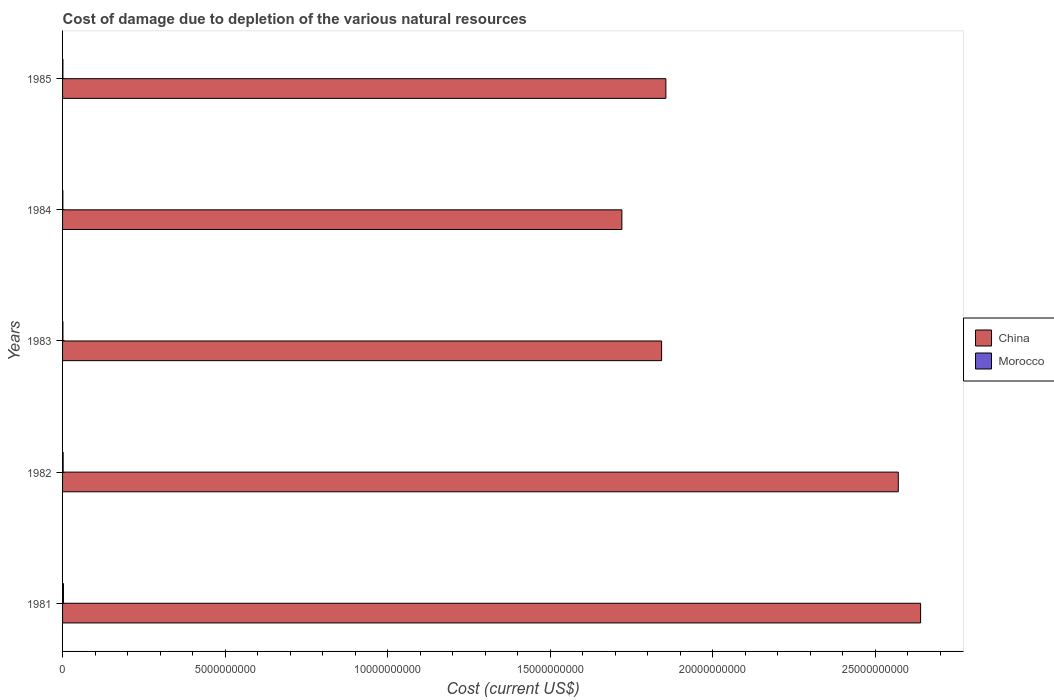How many different coloured bars are there?
Your answer should be very brief. 2. How many groups of bars are there?
Your response must be concise. 5. How many bars are there on the 2nd tick from the top?
Make the answer very short. 2. How many bars are there on the 2nd tick from the bottom?
Your answer should be very brief. 2. What is the label of the 4th group of bars from the top?
Ensure brevity in your answer.  1982. In how many cases, is the number of bars for a given year not equal to the number of legend labels?
Offer a terse response. 0. What is the cost of damage caused due to the depletion of various natural resources in China in 1985?
Offer a very short reply. 1.86e+1. Across all years, what is the maximum cost of damage caused due to the depletion of various natural resources in Morocco?
Make the answer very short. 2.79e+07. Across all years, what is the minimum cost of damage caused due to the depletion of various natural resources in Morocco?
Provide a succinct answer. 8.93e+06. In which year was the cost of damage caused due to the depletion of various natural resources in China maximum?
Offer a terse response. 1981. What is the total cost of damage caused due to the depletion of various natural resources in Morocco in the graph?
Provide a short and direct response. 7.70e+07. What is the difference between the cost of damage caused due to the depletion of various natural resources in Morocco in 1981 and that in 1985?
Give a very brief answer. 1.68e+07. What is the difference between the cost of damage caused due to the depletion of various natural resources in Morocco in 1981 and the cost of damage caused due to the depletion of various natural resources in China in 1983?
Ensure brevity in your answer.  -1.84e+1. What is the average cost of damage caused due to the depletion of various natural resources in Morocco per year?
Your answer should be very brief. 1.54e+07. In the year 1981, what is the difference between the cost of damage caused due to the depletion of various natural resources in China and cost of damage caused due to the depletion of various natural resources in Morocco?
Make the answer very short. 2.64e+1. What is the ratio of the cost of damage caused due to the depletion of various natural resources in Morocco in 1983 to that in 1984?
Provide a succinct answer. 1.24. What is the difference between the highest and the second highest cost of damage caused due to the depletion of various natural resources in China?
Your response must be concise. 6.87e+08. What is the difference between the highest and the lowest cost of damage caused due to the depletion of various natural resources in China?
Provide a short and direct response. 9.19e+09. In how many years, is the cost of damage caused due to the depletion of various natural resources in Morocco greater than the average cost of damage caused due to the depletion of various natural resources in Morocco taken over all years?
Provide a succinct answer. 2. What does the 1st bar from the top in 1982 represents?
Offer a terse response. Morocco. What does the 1st bar from the bottom in 1984 represents?
Offer a terse response. China. How many bars are there?
Your answer should be compact. 10. Does the graph contain any zero values?
Make the answer very short. No. How many legend labels are there?
Give a very brief answer. 2. How are the legend labels stacked?
Your answer should be compact. Vertical. What is the title of the graph?
Offer a terse response. Cost of damage due to depletion of the various natural resources. Does "Trinidad and Tobago" appear as one of the legend labels in the graph?
Offer a very short reply. No. What is the label or title of the X-axis?
Offer a very short reply. Cost (current US$). What is the label or title of the Y-axis?
Offer a terse response. Years. What is the Cost (current US$) in China in 1981?
Provide a succinct answer. 2.64e+1. What is the Cost (current US$) of Morocco in 1981?
Provide a succinct answer. 2.79e+07. What is the Cost (current US$) in China in 1982?
Keep it short and to the point. 2.57e+1. What is the Cost (current US$) in Morocco in 1982?
Your answer should be very brief. 1.80e+07. What is the Cost (current US$) in China in 1983?
Keep it short and to the point. 1.84e+1. What is the Cost (current US$) of Morocco in 1983?
Keep it short and to the point. 1.11e+07. What is the Cost (current US$) of China in 1984?
Provide a short and direct response. 1.72e+1. What is the Cost (current US$) in Morocco in 1984?
Ensure brevity in your answer.  8.93e+06. What is the Cost (current US$) of China in 1985?
Offer a terse response. 1.86e+1. What is the Cost (current US$) in Morocco in 1985?
Give a very brief answer. 1.12e+07. Across all years, what is the maximum Cost (current US$) in China?
Provide a succinct answer. 2.64e+1. Across all years, what is the maximum Cost (current US$) in Morocco?
Keep it short and to the point. 2.79e+07. Across all years, what is the minimum Cost (current US$) in China?
Your response must be concise. 1.72e+1. Across all years, what is the minimum Cost (current US$) in Morocco?
Make the answer very short. 8.93e+06. What is the total Cost (current US$) in China in the graph?
Offer a very short reply. 1.06e+11. What is the total Cost (current US$) of Morocco in the graph?
Provide a succinct answer. 7.70e+07. What is the difference between the Cost (current US$) of China in 1981 and that in 1982?
Your answer should be compact. 6.87e+08. What is the difference between the Cost (current US$) in Morocco in 1981 and that in 1982?
Your answer should be compact. 9.96e+06. What is the difference between the Cost (current US$) of China in 1981 and that in 1983?
Offer a terse response. 7.97e+09. What is the difference between the Cost (current US$) of Morocco in 1981 and that in 1983?
Give a very brief answer. 1.69e+07. What is the difference between the Cost (current US$) in China in 1981 and that in 1984?
Provide a succinct answer. 9.19e+09. What is the difference between the Cost (current US$) of Morocco in 1981 and that in 1984?
Ensure brevity in your answer.  1.90e+07. What is the difference between the Cost (current US$) of China in 1981 and that in 1985?
Make the answer very short. 7.84e+09. What is the difference between the Cost (current US$) in Morocco in 1981 and that in 1985?
Make the answer very short. 1.68e+07. What is the difference between the Cost (current US$) in China in 1982 and that in 1983?
Offer a very short reply. 7.28e+09. What is the difference between the Cost (current US$) of Morocco in 1982 and that in 1983?
Make the answer very short. 6.90e+06. What is the difference between the Cost (current US$) in China in 1982 and that in 1984?
Your response must be concise. 8.50e+09. What is the difference between the Cost (current US$) of Morocco in 1982 and that in 1984?
Your answer should be compact. 9.04e+06. What is the difference between the Cost (current US$) of China in 1982 and that in 1985?
Your response must be concise. 7.15e+09. What is the difference between the Cost (current US$) in Morocco in 1982 and that in 1985?
Provide a short and direct response. 6.82e+06. What is the difference between the Cost (current US$) of China in 1983 and that in 1984?
Provide a short and direct response. 1.22e+09. What is the difference between the Cost (current US$) in Morocco in 1983 and that in 1984?
Your answer should be very brief. 2.14e+06. What is the difference between the Cost (current US$) of China in 1983 and that in 1985?
Provide a succinct answer. -1.31e+08. What is the difference between the Cost (current US$) of Morocco in 1983 and that in 1985?
Provide a succinct answer. -8.16e+04. What is the difference between the Cost (current US$) in China in 1984 and that in 1985?
Your response must be concise. -1.35e+09. What is the difference between the Cost (current US$) of Morocco in 1984 and that in 1985?
Provide a succinct answer. -2.23e+06. What is the difference between the Cost (current US$) in China in 1981 and the Cost (current US$) in Morocco in 1982?
Your answer should be compact. 2.64e+1. What is the difference between the Cost (current US$) of China in 1981 and the Cost (current US$) of Morocco in 1983?
Keep it short and to the point. 2.64e+1. What is the difference between the Cost (current US$) of China in 1981 and the Cost (current US$) of Morocco in 1984?
Provide a short and direct response. 2.64e+1. What is the difference between the Cost (current US$) in China in 1981 and the Cost (current US$) in Morocco in 1985?
Provide a succinct answer. 2.64e+1. What is the difference between the Cost (current US$) of China in 1982 and the Cost (current US$) of Morocco in 1983?
Give a very brief answer. 2.57e+1. What is the difference between the Cost (current US$) in China in 1982 and the Cost (current US$) in Morocco in 1984?
Make the answer very short. 2.57e+1. What is the difference between the Cost (current US$) in China in 1982 and the Cost (current US$) in Morocco in 1985?
Your answer should be compact. 2.57e+1. What is the difference between the Cost (current US$) in China in 1983 and the Cost (current US$) in Morocco in 1984?
Keep it short and to the point. 1.84e+1. What is the difference between the Cost (current US$) of China in 1983 and the Cost (current US$) of Morocco in 1985?
Your answer should be compact. 1.84e+1. What is the difference between the Cost (current US$) of China in 1984 and the Cost (current US$) of Morocco in 1985?
Offer a terse response. 1.72e+1. What is the average Cost (current US$) in China per year?
Ensure brevity in your answer.  2.13e+1. What is the average Cost (current US$) of Morocco per year?
Make the answer very short. 1.54e+07. In the year 1981, what is the difference between the Cost (current US$) of China and Cost (current US$) of Morocco?
Your answer should be compact. 2.64e+1. In the year 1982, what is the difference between the Cost (current US$) in China and Cost (current US$) in Morocco?
Keep it short and to the point. 2.57e+1. In the year 1983, what is the difference between the Cost (current US$) in China and Cost (current US$) in Morocco?
Make the answer very short. 1.84e+1. In the year 1984, what is the difference between the Cost (current US$) of China and Cost (current US$) of Morocco?
Give a very brief answer. 1.72e+1. In the year 1985, what is the difference between the Cost (current US$) in China and Cost (current US$) in Morocco?
Offer a very short reply. 1.85e+1. What is the ratio of the Cost (current US$) of China in 1981 to that in 1982?
Your answer should be very brief. 1.03. What is the ratio of the Cost (current US$) of Morocco in 1981 to that in 1982?
Keep it short and to the point. 1.55. What is the ratio of the Cost (current US$) in China in 1981 to that in 1983?
Offer a very short reply. 1.43. What is the ratio of the Cost (current US$) in Morocco in 1981 to that in 1983?
Your answer should be very brief. 2.52. What is the ratio of the Cost (current US$) of China in 1981 to that in 1984?
Ensure brevity in your answer.  1.53. What is the ratio of the Cost (current US$) of Morocco in 1981 to that in 1984?
Your answer should be very brief. 3.13. What is the ratio of the Cost (current US$) of China in 1981 to that in 1985?
Offer a terse response. 1.42. What is the ratio of the Cost (current US$) of Morocco in 1981 to that in 1985?
Make the answer very short. 2.5. What is the ratio of the Cost (current US$) in China in 1982 to that in 1983?
Make the answer very short. 1.4. What is the ratio of the Cost (current US$) in Morocco in 1982 to that in 1983?
Your answer should be compact. 1.62. What is the ratio of the Cost (current US$) in China in 1982 to that in 1984?
Your response must be concise. 1.49. What is the ratio of the Cost (current US$) in Morocco in 1982 to that in 1984?
Offer a very short reply. 2.01. What is the ratio of the Cost (current US$) in China in 1982 to that in 1985?
Provide a succinct answer. 1.39. What is the ratio of the Cost (current US$) of Morocco in 1982 to that in 1985?
Keep it short and to the point. 1.61. What is the ratio of the Cost (current US$) of China in 1983 to that in 1984?
Your answer should be compact. 1.07. What is the ratio of the Cost (current US$) of Morocco in 1983 to that in 1984?
Provide a short and direct response. 1.24. What is the ratio of the Cost (current US$) of China in 1984 to that in 1985?
Ensure brevity in your answer.  0.93. What is the ratio of the Cost (current US$) in Morocco in 1984 to that in 1985?
Ensure brevity in your answer.  0.8. What is the difference between the highest and the second highest Cost (current US$) of China?
Your answer should be very brief. 6.87e+08. What is the difference between the highest and the second highest Cost (current US$) of Morocco?
Provide a succinct answer. 9.96e+06. What is the difference between the highest and the lowest Cost (current US$) in China?
Your answer should be compact. 9.19e+09. What is the difference between the highest and the lowest Cost (current US$) in Morocco?
Provide a succinct answer. 1.90e+07. 